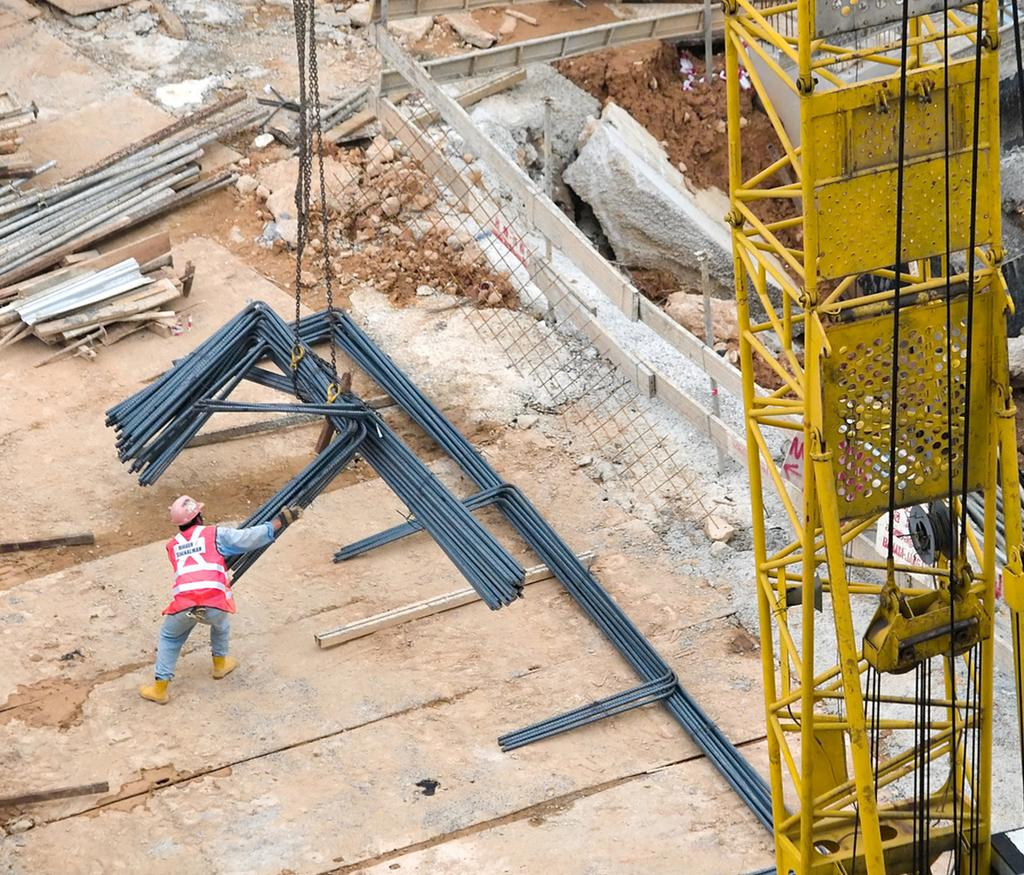What is the man in the image doing? The man is standing in the image and holding metal rods. What else can be seen in the image related to the metal rods? There is a crane holding metal rods in the image. Can you describe the man's attire in the image? The man is wearing a cap. What type of barrier is present in the image? There is a wooden fence in the image. What type of wash is the man performing on his teeth in the image? There is no mention of teeth or washing in the image; the man is holding metal rods and standing near a crane. 